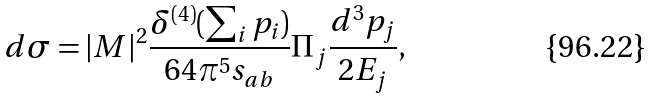<formula> <loc_0><loc_0><loc_500><loc_500>d \sigma = | M | ^ { 2 } \frac { \delta ^ { ( 4 ) } ( \sum _ { i } p _ { i } ) } { 6 4 \pi ^ { 5 } s _ { a b } } \Pi _ { j } \frac { d ^ { 3 } p _ { j } } { 2 E _ { j } } ,</formula> 